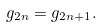Convert formula to latex. <formula><loc_0><loc_0><loc_500><loc_500>g _ { 2 n } = g _ { 2 n + 1 } .</formula> 